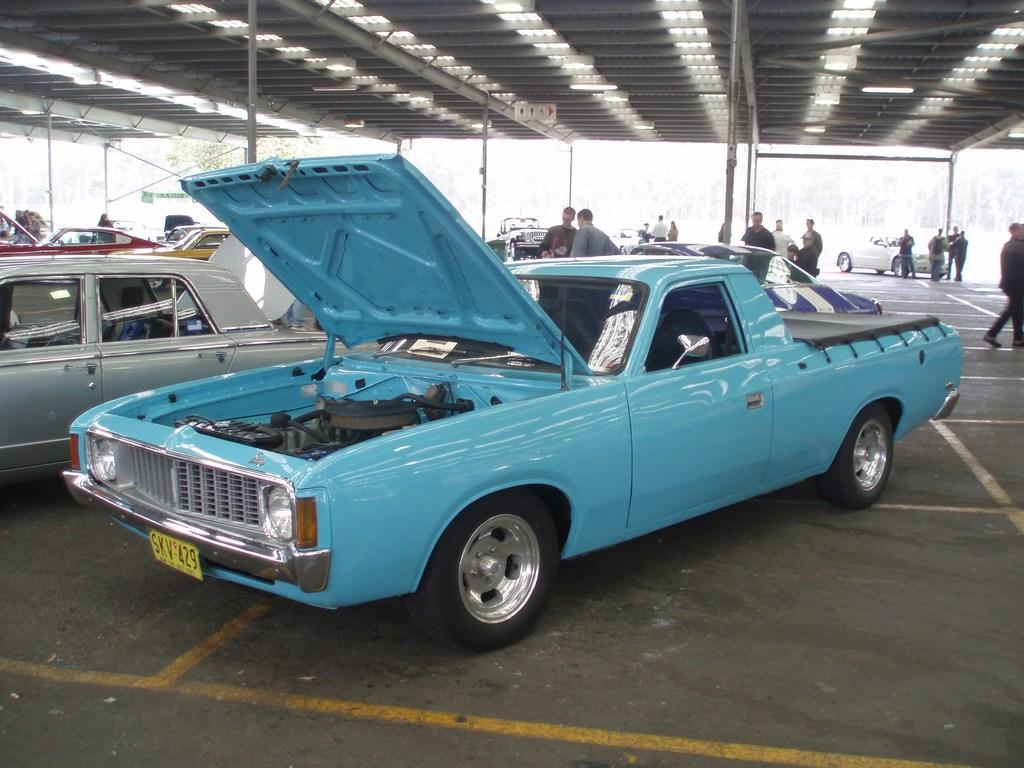What is the main subject of the image? The main subject of the image is a group of vehicles. Where are the vehicles located in the image? The vehicles are parked in a parking lot. What else can be seen in the background of the image? There is a group of people standing, a group of poles, and a shed in the background of the image. What type of dirt can be seen covering the station in the image? There is no station or dirt present in the image. What kind of pipe is visible connecting the vehicles in the image? There are no pipes connecting the vehicles in the image. 